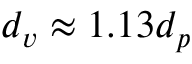Convert formula to latex. <formula><loc_0><loc_0><loc_500><loc_500>d _ { v } \approx 1 . 1 3 d _ { p }</formula> 